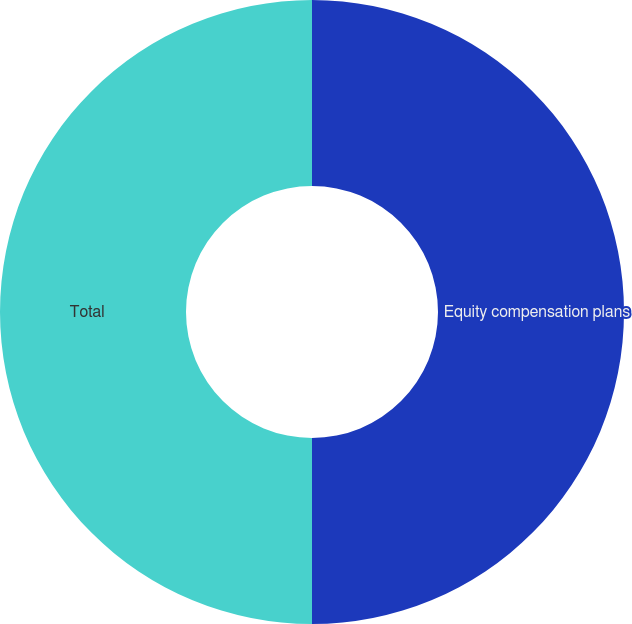<chart> <loc_0><loc_0><loc_500><loc_500><pie_chart><fcel>Equity compensation plans<fcel>Total<nl><fcel>50.0%<fcel>50.0%<nl></chart> 